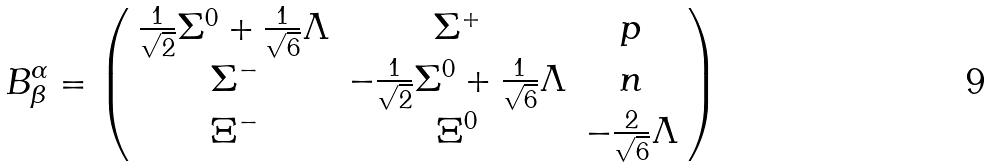<formula> <loc_0><loc_0><loc_500><loc_500>B _ { \beta } ^ { \alpha } = \left ( \begin{array} { c c c } \frac { 1 } { \sqrt { 2 } } \Sigma ^ { 0 } + \frac { 1 } { \sqrt { 6 } } \Lambda & \Sigma ^ { + } & p \\ \Sigma ^ { - } & - \frac { 1 } { \sqrt { 2 } } \Sigma ^ { 0 } + \frac { 1 } { \sqrt { 6 } } \Lambda & n \\ \Xi ^ { - } & \Xi ^ { 0 } & - \frac { 2 } { \sqrt { 6 } } \Lambda \end{array} \right )</formula> 